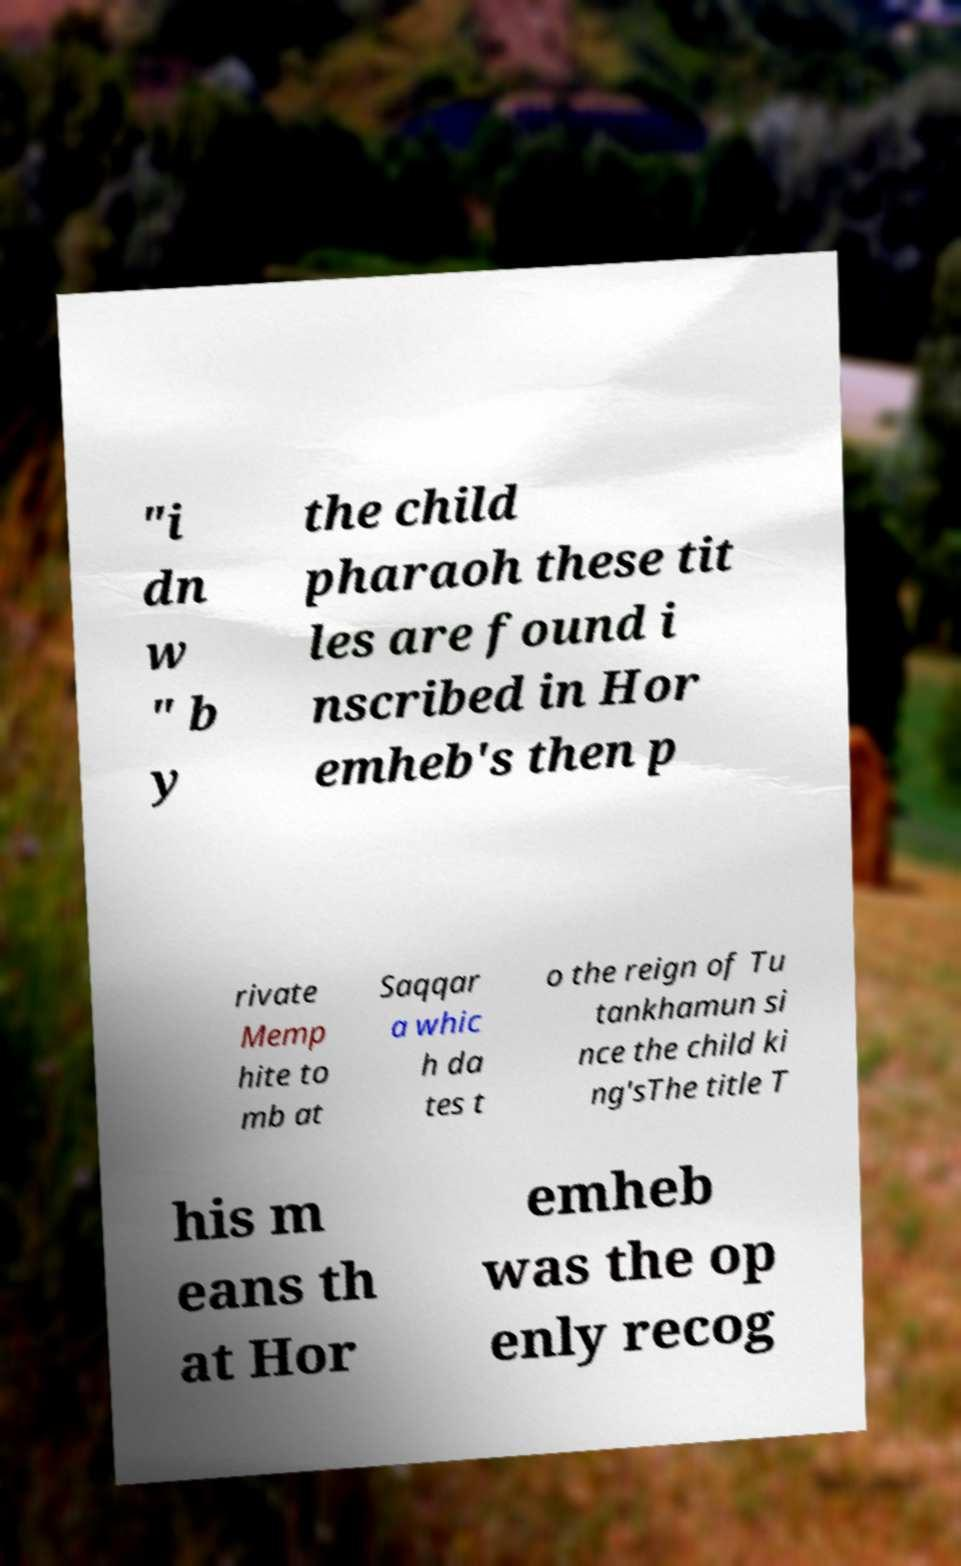Please read and relay the text visible in this image. What does it say? "i dn w " b y the child pharaoh these tit les are found i nscribed in Hor emheb's then p rivate Memp hite to mb at Saqqar a whic h da tes t o the reign of Tu tankhamun si nce the child ki ng'sThe title T his m eans th at Hor emheb was the op enly recog 